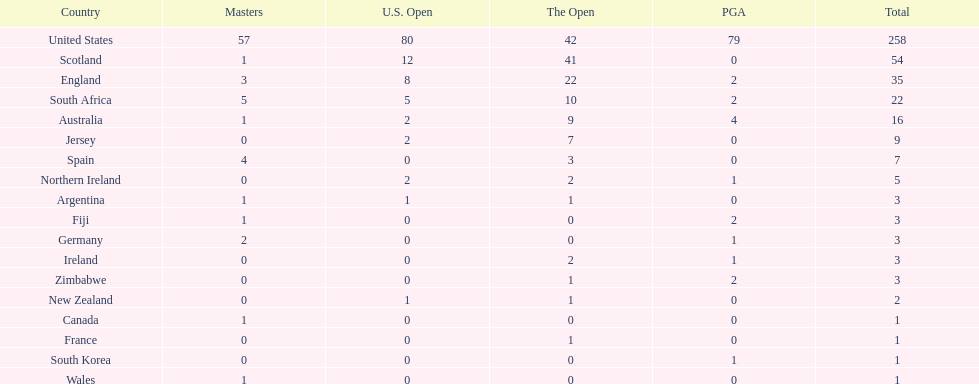Which african country has the least champion golfers according to this table? Zimbabwe. 